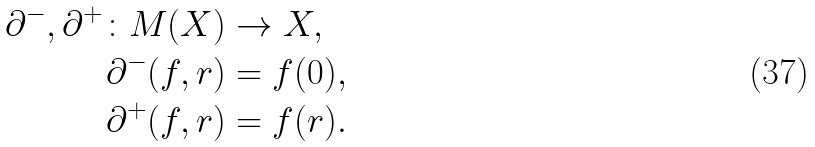<formula> <loc_0><loc_0><loc_500><loc_500>\partial ^ { - } , \partial ^ { + } \colon M ( X ) & \to X , \\ \partial ^ { - } ( f , r ) & = f ( 0 ) , \\ \partial ^ { + } ( f , r ) & = f ( r ) .</formula> 